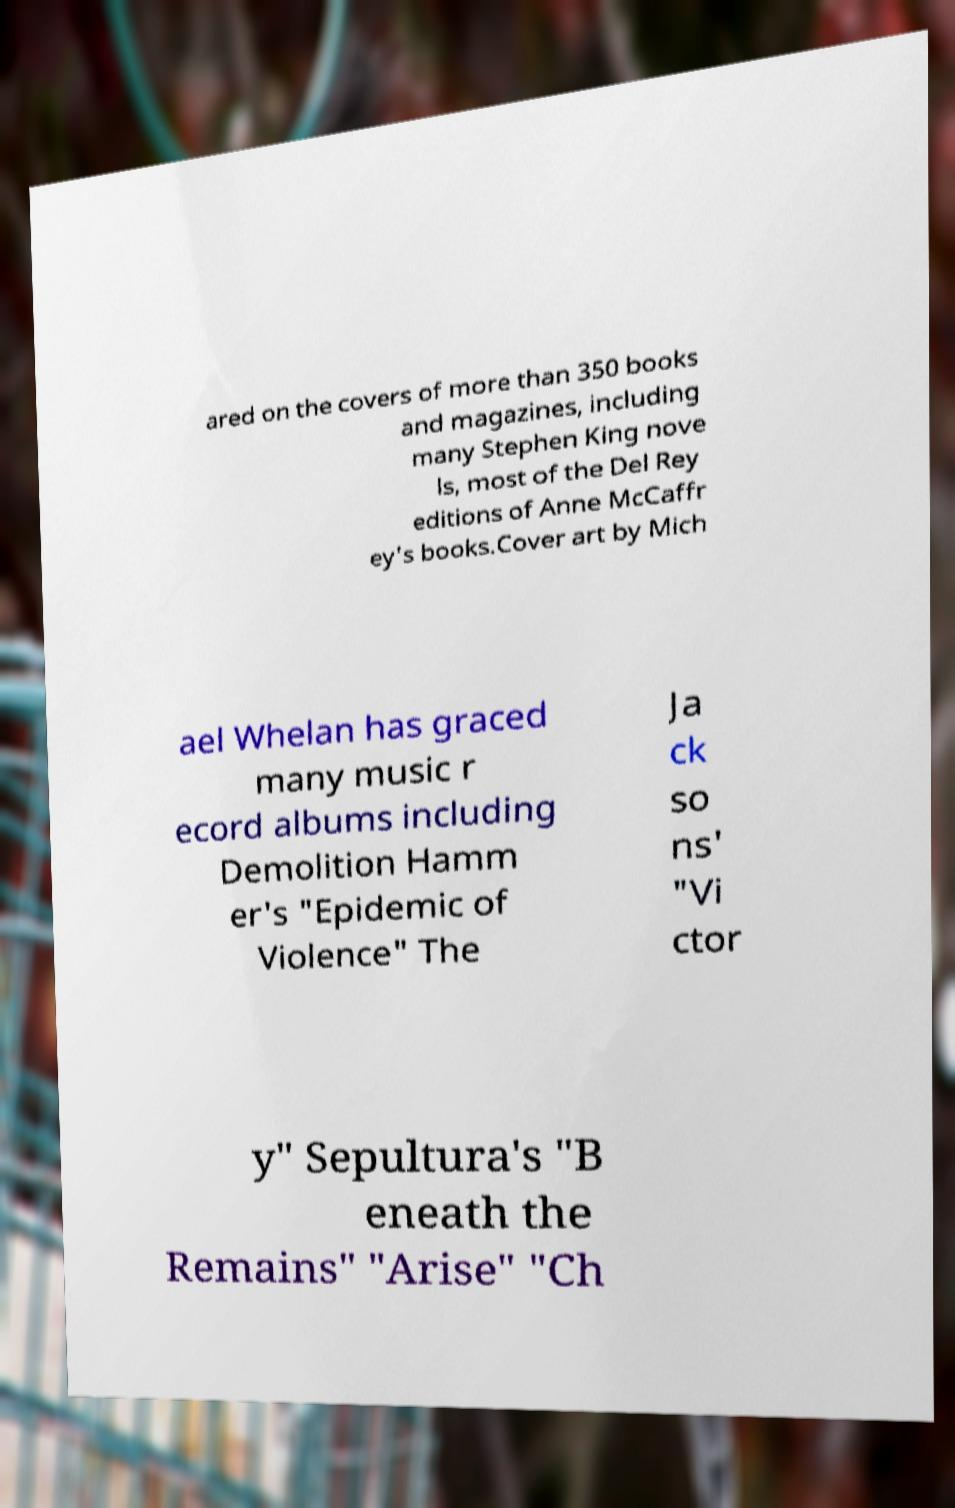Please identify and transcribe the text found in this image. ared on the covers of more than 350 books and magazines, including many Stephen King nove ls, most of the Del Rey editions of Anne McCaffr ey's books.Cover art by Mich ael Whelan has graced many music r ecord albums including Demolition Hamm er's "Epidemic of Violence" The Ja ck so ns' "Vi ctor y" Sepultura's "B eneath the Remains" "Arise" "Ch 